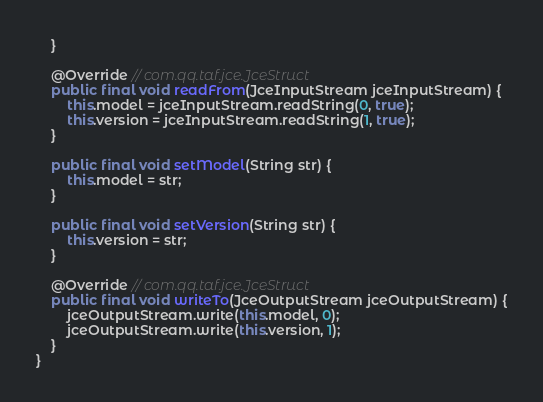<code> <loc_0><loc_0><loc_500><loc_500><_Java_>    }

    @Override // com.qq.taf.jce.JceStruct
    public final void readFrom(JceInputStream jceInputStream) {
        this.model = jceInputStream.readString(0, true);
        this.version = jceInputStream.readString(1, true);
    }

    public final void setModel(String str) {
        this.model = str;
    }

    public final void setVersion(String str) {
        this.version = str;
    }

    @Override // com.qq.taf.jce.JceStruct
    public final void writeTo(JceOutputStream jceOutputStream) {
        jceOutputStream.write(this.model, 0);
        jceOutputStream.write(this.version, 1);
    }
}
</code> 